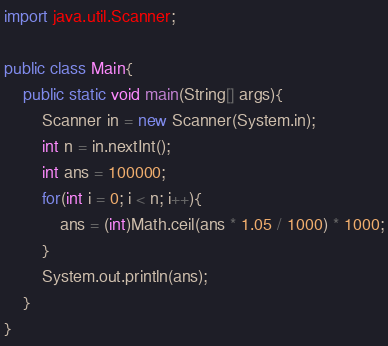Convert code to text. <code><loc_0><loc_0><loc_500><loc_500><_Java_>import java.util.Scanner;

public class Main{
    public static void main(String[] args){
        Scanner in = new Scanner(System.in);
        int n = in.nextInt();
        int ans = 100000;
        for(int i = 0; i < n; i++){
            ans = (int)Math.ceil(ans * 1.05 / 1000) * 1000;
        }
        System.out.println(ans);
    }
}</code> 